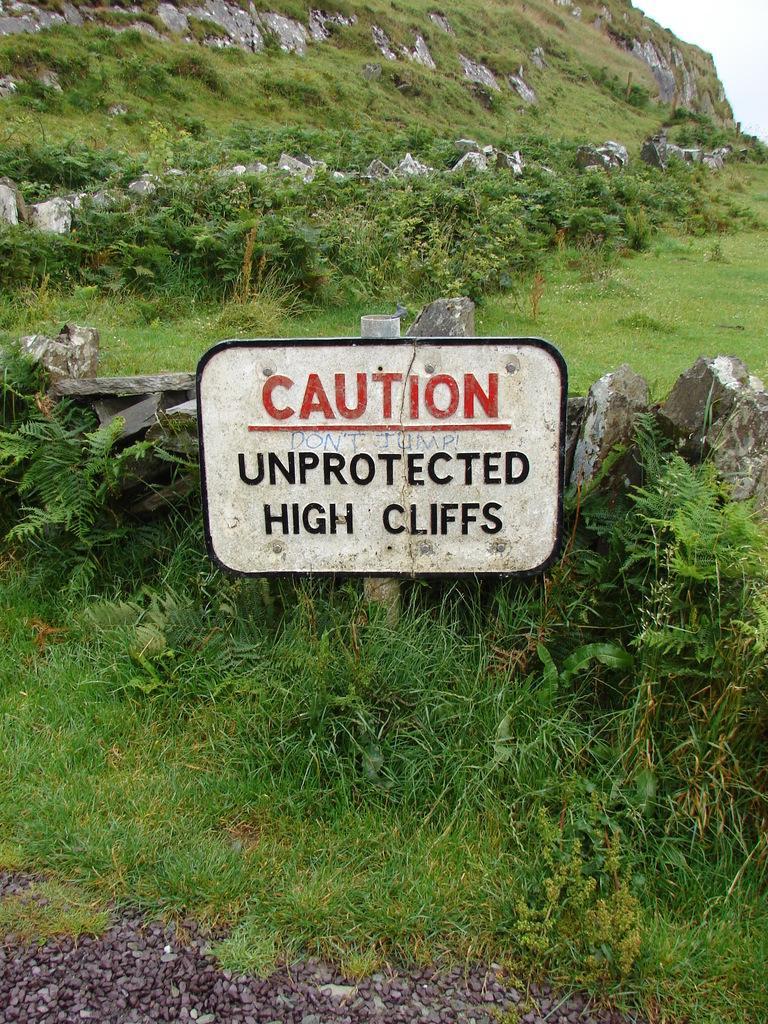Describe this image in one or two sentences. This image consists of a mountain along with trees and rocks. At the bottom, there is green grass on the ground. And we can see a board in white color. 